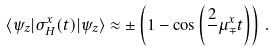Convert formula to latex. <formula><loc_0><loc_0><loc_500><loc_500>\langle \psi _ { z } | \sigma ^ { x } _ { H } ( t ) | \psi _ { z } \rangle \approx \pm \left ( 1 - \cos \left ( \frac { 2 } { } \mu ^ { x } _ { \mp } t \right ) \right ) \, .</formula> 